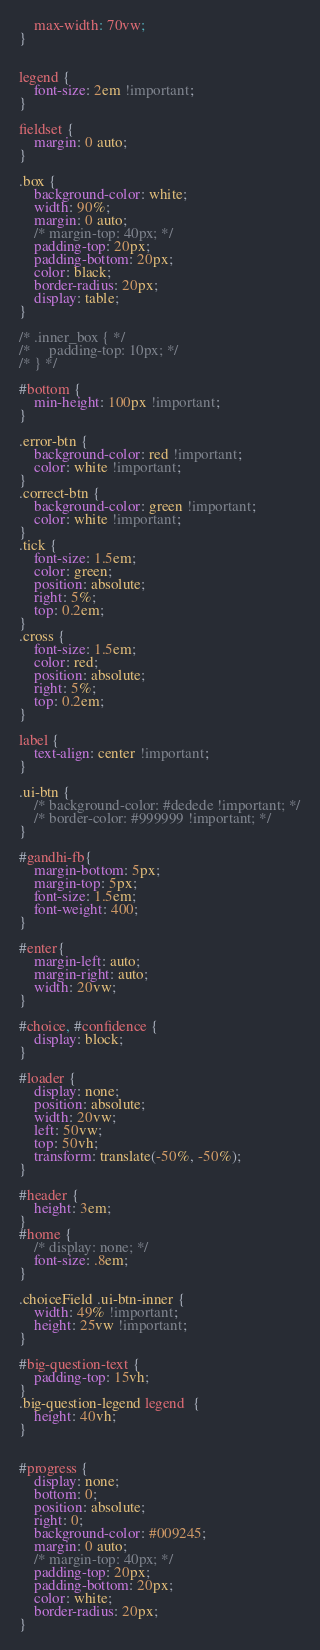<code> <loc_0><loc_0><loc_500><loc_500><_CSS_>    max-width: 70vw;
}
    

legend {
    font-size: 2em !important;
}

fieldset {
    margin: 0 auto;    
}

.box {
    background-color: white;
    width: 90%;
    margin: 0 auto;
    /* margin-top: 40px; */
    padding-top: 20px;
    padding-bottom: 20px;
    color: black;
    border-radius: 20px;
    display: table;
}

/* .inner_box { */
/*     padding-top: 10px; */
/* } */

#bottom {
    min-height: 100px !important;
}

.error-btn {
    background-color: red !important;
    color: white !important;
}
.correct-btn {
    background-color: green !important;
    color: white !important;
}
.tick {
    font-size: 1.5em;
    color: green;
    position: absolute;
    right: 5%;
    top: 0.2em;    
}
.cross {
    font-size: 1.5em;
    color: red;
    position: absolute;
    right: 5%;
    top: 0.2em;    
}

label {
    text-align: center !important;
}

.ui-btn {
    /* background-color: #dedede !important; */
    /* border-color: #999999 !important; */
}

#gandhi-fb{
    margin-bottom: 5px;
    margin-top: 5px;
    font-size: 1.5em;
    font-weight: 400;    
}

#enter{
    margin-left: auto;
    margin-right: auto;
    width: 20vw;
}

#choice, #confidence {
    display: block;
}

#loader {
    display: none;
    position: absolute;
    width: 20vw;
    left: 50vw;
    top: 50vh;
    transform: translate(-50%, -50%);
}

#header {
    height: 3em;
}
#home {
    /* display: none; */
    font-size: .8em;
}

.choiceField .ui-btn-inner {
    width: 49% !important;
    height: 25vw !important;
}

#big-question-text {
    padding-top: 15vh;
}
.big-question-legend legend  {
    height: 40vh;
}


#progress {
    display: none;
    bottom: 0;
    position: absolute;
    right: 0;
    background-color: #009245;
    margin: 0 auto;
    /* margin-top: 40px; */
    padding-top: 20px;
    padding-bottom: 20px;
    color: white;
    border-radius: 20px;
}
</code> 